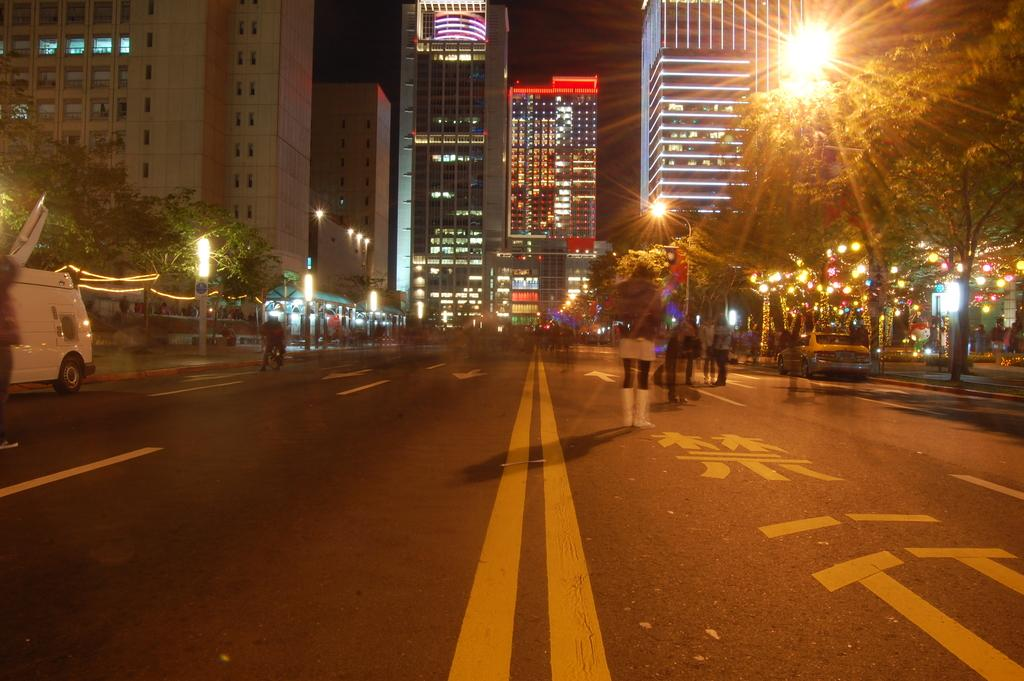What is the main feature of the image? There is a road in the image. What can be seen on the road? There are vehicles on the road. Are there any people present in the image? Yes, there are people in the image. What can be seen on either side of the road? There are light poles and trees on either side of the road. What is visible in the background of the image? There are buildings visible in the background of the image. What type of competition is taking place on the road in the image? There is no competition taking place on the road in the image. What time of day is it in the image? The time of day cannot be determined from the image alone. 